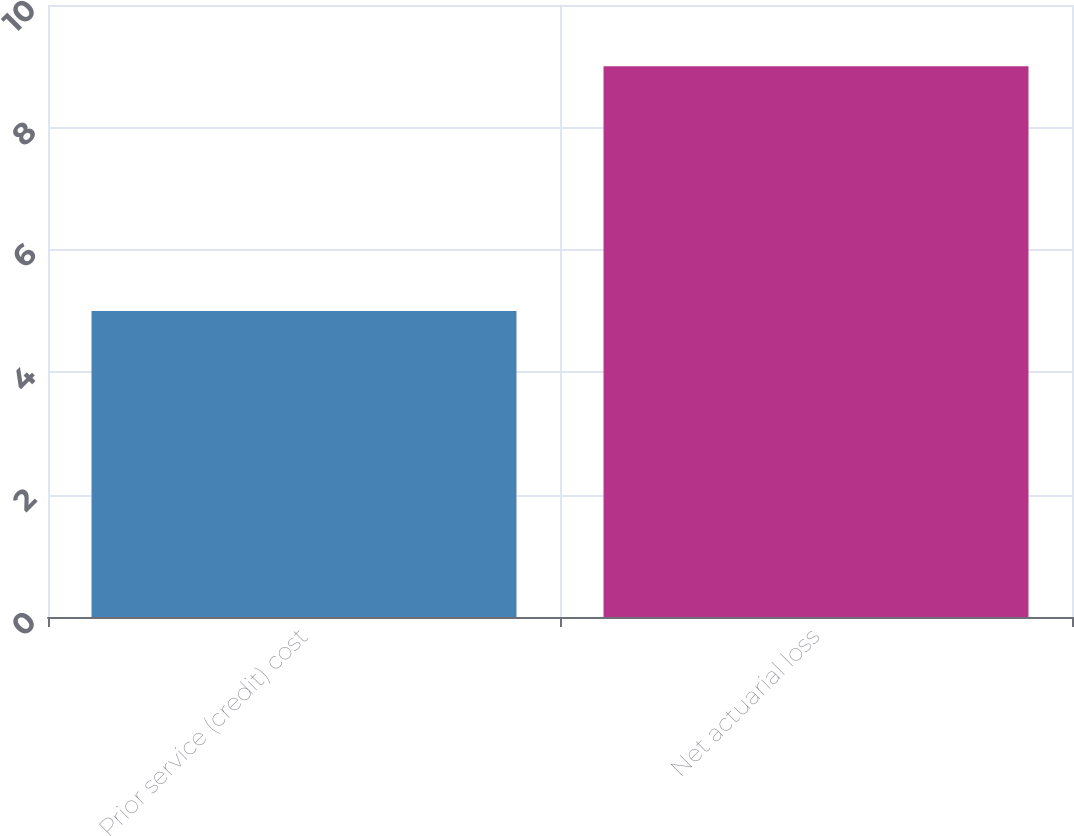Convert chart. <chart><loc_0><loc_0><loc_500><loc_500><bar_chart><fcel>Prior service (credit) cost<fcel>Net actuarial loss<nl><fcel>5<fcel>9<nl></chart> 